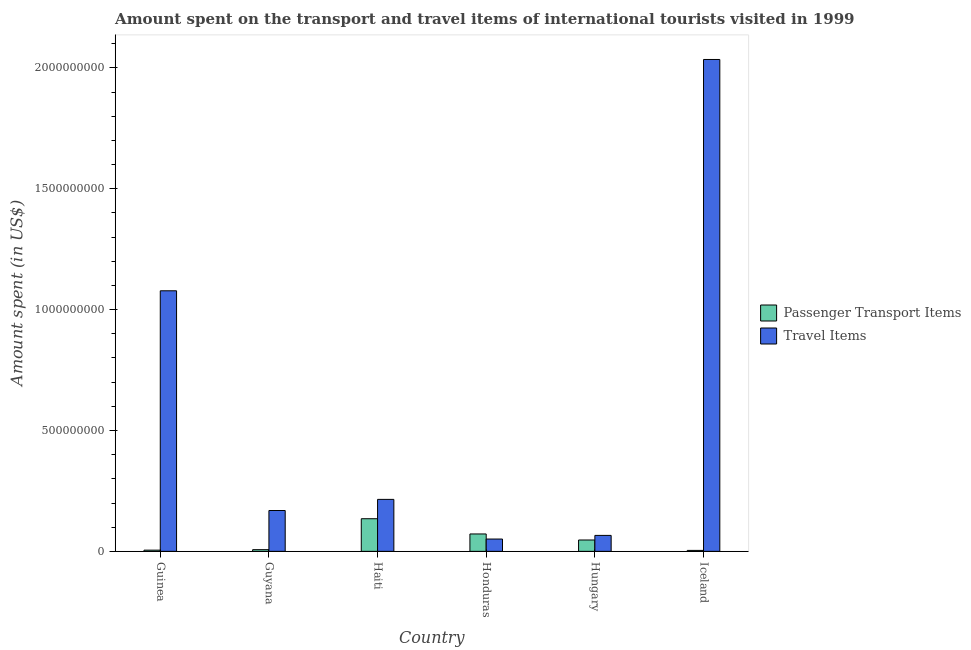How many groups of bars are there?
Keep it short and to the point. 6. Are the number of bars per tick equal to the number of legend labels?
Provide a succinct answer. Yes. Are the number of bars on each tick of the X-axis equal?
Offer a very short reply. Yes. How many bars are there on the 3rd tick from the left?
Make the answer very short. 2. What is the label of the 4th group of bars from the left?
Give a very brief answer. Honduras. In how many cases, is the number of bars for a given country not equal to the number of legend labels?
Provide a short and direct response. 0. What is the amount spent in travel items in Guyana?
Your answer should be very brief. 1.69e+08. Across all countries, what is the maximum amount spent on passenger transport items?
Your answer should be very brief. 1.35e+08. Across all countries, what is the minimum amount spent in travel items?
Your answer should be compact. 5.10e+07. In which country was the amount spent on passenger transport items maximum?
Give a very brief answer. Haiti. In which country was the amount spent in travel items minimum?
Ensure brevity in your answer.  Honduras. What is the total amount spent on passenger transport items in the graph?
Offer a very short reply. 2.70e+08. What is the difference between the amount spent in travel items in Guinea and that in Haiti?
Offer a very short reply. 8.63e+08. What is the difference between the amount spent on passenger transport items in Iceland and the amount spent in travel items in Guinea?
Provide a succinct answer. -1.07e+09. What is the average amount spent in travel items per country?
Ensure brevity in your answer.  6.02e+08. What is the difference between the amount spent in travel items and amount spent on passenger transport items in Honduras?
Make the answer very short. -2.10e+07. What is the ratio of the amount spent on passenger transport items in Haiti to that in Hungary?
Provide a succinct answer. 2.87. Is the amount spent on passenger transport items in Guyana less than that in Honduras?
Your answer should be very brief. Yes. Is the difference between the amount spent on passenger transport items in Hungary and Iceland greater than the difference between the amount spent in travel items in Hungary and Iceland?
Offer a terse response. Yes. What is the difference between the highest and the second highest amount spent in travel items?
Keep it short and to the point. 9.57e+08. What is the difference between the highest and the lowest amount spent on passenger transport items?
Your response must be concise. 1.31e+08. What does the 1st bar from the left in Hungary represents?
Your answer should be compact. Passenger Transport Items. What does the 2nd bar from the right in Guyana represents?
Your response must be concise. Passenger Transport Items. Are all the bars in the graph horizontal?
Provide a short and direct response. No. What is the difference between two consecutive major ticks on the Y-axis?
Provide a succinct answer. 5.00e+08. Are the values on the major ticks of Y-axis written in scientific E-notation?
Offer a terse response. No. Does the graph contain any zero values?
Your response must be concise. No. Where does the legend appear in the graph?
Your response must be concise. Center right. How many legend labels are there?
Your answer should be very brief. 2. How are the legend labels stacked?
Ensure brevity in your answer.  Vertical. What is the title of the graph?
Your answer should be very brief. Amount spent on the transport and travel items of international tourists visited in 1999. Does "Death rate" appear as one of the legend labels in the graph?
Provide a succinct answer. No. What is the label or title of the Y-axis?
Give a very brief answer. Amount spent (in US$). What is the Amount spent (in US$) in Travel Items in Guinea?
Keep it short and to the point. 1.08e+09. What is the Amount spent (in US$) in Passenger Transport Items in Guyana?
Provide a succinct answer. 7.00e+06. What is the Amount spent (in US$) of Travel Items in Guyana?
Provide a succinct answer. 1.69e+08. What is the Amount spent (in US$) of Passenger Transport Items in Haiti?
Provide a succinct answer. 1.35e+08. What is the Amount spent (in US$) of Travel Items in Haiti?
Keep it short and to the point. 2.15e+08. What is the Amount spent (in US$) of Passenger Transport Items in Honduras?
Make the answer very short. 7.20e+07. What is the Amount spent (in US$) of Travel Items in Honduras?
Ensure brevity in your answer.  5.10e+07. What is the Amount spent (in US$) of Passenger Transport Items in Hungary?
Your response must be concise. 4.70e+07. What is the Amount spent (in US$) in Travel Items in Hungary?
Your answer should be compact. 6.60e+07. What is the Amount spent (in US$) of Travel Items in Iceland?
Your answer should be compact. 2.04e+09. Across all countries, what is the maximum Amount spent (in US$) in Passenger Transport Items?
Your response must be concise. 1.35e+08. Across all countries, what is the maximum Amount spent (in US$) in Travel Items?
Your answer should be very brief. 2.04e+09. Across all countries, what is the minimum Amount spent (in US$) of Passenger Transport Items?
Give a very brief answer. 4.00e+06. Across all countries, what is the minimum Amount spent (in US$) in Travel Items?
Provide a succinct answer. 5.10e+07. What is the total Amount spent (in US$) in Passenger Transport Items in the graph?
Your response must be concise. 2.70e+08. What is the total Amount spent (in US$) in Travel Items in the graph?
Keep it short and to the point. 3.61e+09. What is the difference between the Amount spent (in US$) of Passenger Transport Items in Guinea and that in Guyana?
Offer a terse response. -2.00e+06. What is the difference between the Amount spent (in US$) in Travel Items in Guinea and that in Guyana?
Your answer should be compact. 9.09e+08. What is the difference between the Amount spent (in US$) in Passenger Transport Items in Guinea and that in Haiti?
Offer a terse response. -1.30e+08. What is the difference between the Amount spent (in US$) of Travel Items in Guinea and that in Haiti?
Your response must be concise. 8.63e+08. What is the difference between the Amount spent (in US$) in Passenger Transport Items in Guinea and that in Honduras?
Your answer should be very brief. -6.70e+07. What is the difference between the Amount spent (in US$) of Travel Items in Guinea and that in Honduras?
Your answer should be compact. 1.03e+09. What is the difference between the Amount spent (in US$) of Passenger Transport Items in Guinea and that in Hungary?
Offer a terse response. -4.20e+07. What is the difference between the Amount spent (in US$) of Travel Items in Guinea and that in Hungary?
Your answer should be compact. 1.01e+09. What is the difference between the Amount spent (in US$) in Passenger Transport Items in Guinea and that in Iceland?
Your answer should be compact. 1.00e+06. What is the difference between the Amount spent (in US$) of Travel Items in Guinea and that in Iceland?
Offer a terse response. -9.57e+08. What is the difference between the Amount spent (in US$) of Passenger Transport Items in Guyana and that in Haiti?
Offer a terse response. -1.28e+08. What is the difference between the Amount spent (in US$) of Travel Items in Guyana and that in Haiti?
Your response must be concise. -4.60e+07. What is the difference between the Amount spent (in US$) of Passenger Transport Items in Guyana and that in Honduras?
Provide a short and direct response. -6.50e+07. What is the difference between the Amount spent (in US$) of Travel Items in Guyana and that in Honduras?
Provide a succinct answer. 1.18e+08. What is the difference between the Amount spent (in US$) in Passenger Transport Items in Guyana and that in Hungary?
Ensure brevity in your answer.  -4.00e+07. What is the difference between the Amount spent (in US$) of Travel Items in Guyana and that in Hungary?
Offer a very short reply. 1.03e+08. What is the difference between the Amount spent (in US$) in Travel Items in Guyana and that in Iceland?
Make the answer very short. -1.87e+09. What is the difference between the Amount spent (in US$) of Passenger Transport Items in Haiti and that in Honduras?
Ensure brevity in your answer.  6.30e+07. What is the difference between the Amount spent (in US$) of Travel Items in Haiti and that in Honduras?
Ensure brevity in your answer.  1.64e+08. What is the difference between the Amount spent (in US$) in Passenger Transport Items in Haiti and that in Hungary?
Provide a succinct answer. 8.80e+07. What is the difference between the Amount spent (in US$) in Travel Items in Haiti and that in Hungary?
Offer a terse response. 1.49e+08. What is the difference between the Amount spent (in US$) in Passenger Transport Items in Haiti and that in Iceland?
Offer a very short reply. 1.31e+08. What is the difference between the Amount spent (in US$) of Travel Items in Haiti and that in Iceland?
Your answer should be very brief. -1.82e+09. What is the difference between the Amount spent (in US$) of Passenger Transport Items in Honduras and that in Hungary?
Provide a succinct answer. 2.50e+07. What is the difference between the Amount spent (in US$) in Travel Items in Honduras and that in Hungary?
Provide a short and direct response. -1.50e+07. What is the difference between the Amount spent (in US$) of Passenger Transport Items in Honduras and that in Iceland?
Keep it short and to the point. 6.80e+07. What is the difference between the Amount spent (in US$) of Travel Items in Honduras and that in Iceland?
Offer a very short reply. -1.98e+09. What is the difference between the Amount spent (in US$) in Passenger Transport Items in Hungary and that in Iceland?
Give a very brief answer. 4.30e+07. What is the difference between the Amount spent (in US$) in Travel Items in Hungary and that in Iceland?
Keep it short and to the point. -1.97e+09. What is the difference between the Amount spent (in US$) of Passenger Transport Items in Guinea and the Amount spent (in US$) of Travel Items in Guyana?
Keep it short and to the point. -1.64e+08. What is the difference between the Amount spent (in US$) in Passenger Transport Items in Guinea and the Amount spent (in US$) in Travel Items in Haiti?
Offer a very short reply. -2.10e+08. What is the difference between the Amount spent (in US$) in Passenger Transport Items in Guinea and the Amount spent (in US$) in Travel Items in Honduras?
Your response must be concise. -4.60e+07. What is the difference between the Amount spent (in US$) of Passenger Transport Items in Guinea and the Amount spent (in US$) of Travel Items in Hungary?
Make the answer very short. -6.10e+07. What is the difference between the Amount spent (in US$) in Passenger Transport Items in Guinea and the Amount spent (in US$) in Travel Items in Iceland?
Keep it short and to the point. -2.03e+09. What is the difference between the Amount spent (in US$) of Passenger Transport Items in Guyana and the Amount spent (in US$) of Travel Items in Haiti?
Ensure brevity in your answer.  -2.08e+08. What is the difference between the Amount spent (in US$) in Passenger Transport Items in Guyana and the Amount spent (in US$) in Travel Items in Honduras?
Provide a succinct answer. -4.40e+07. What is the difference between the Amount spent (in US$) in Passenger Transport Items in Guyana and the Amount spent (in US$) in Travel Items in Hungary?
Give a very brief answer. -5.90e+07. What is the difference between the Amount spent (in US$) of Passenger Transport Items in Guyana and the Amount spent (in US$) of Travel Items in Iceland?
Provide a short and direct response. -2.03e+09. What is the difference between the Amount spent (in US$) of Passenger Transport Items in Haiti and the Amount spent (in US$) of Travel Items in Honduras?
Your response must be concise. 8.40e+07. What is the difference between the Amount spent (in US$) in Passenger Transport Items in Haiti and the Amount spent (in US$) in Travel Items in Hungary?
Your answer should be compact. 6.90e+07. What is the difference between the Amount spent (in US$) of Passenger Transport Items in Haiti and the Amount spent (in US$) of Travel Items in Iceland?
Provide a short and direct response. -1.90e+09. What is the difference between the Amount spent (in US$) of Passenger Transport Items in Honduras and the Amount spent (in US$) of Travel Items in Hungary?
Offer a terse response. 6.00e+06. What is the difference between the Amount spent (in US$) in Passenger Transport Items in Honduras and the Amount spent (in US$) in Travel Items in Iceland?
Offer a very short reply. -1.96e+09. What is the difference between the Amount spent (in US$) of Passenger Transport Items in Hungary and the Amount spent (in US$) of Travel Items in Iceland?
Provide a succinct answer. -1.99e+09. What is the average Amount spent (in US$) in Passenger Transport Items per country?
Provide a succinct answer. 4.50e+07. What is the average Amount spent (in US$) of Travel Items per country?
Offer a very short reply. 6.02e+08. What is the difference between the Amount spent (in US$) in Passenger Transport Items and Amount spent (in US$) in Travel Items in Guinea?
Your response must be concise. -1.07e+09. What is the difference between the Amount spent (in US$) of Passenger Transport Items and Amount spent (in US$) of Travel Items in Guyana?
Provide a succinct answer. -1.62e+08. What is the difference between the Amount spent (in US$) in Passenger Transport Items and Amount spent (in US$) in Travel Items in Haiti?
Your response must be concise. -8.00e+07. What is the difference between the Amount spent (in US$) in Passenger Transport Items and Amount spent (in US$) in Travel Items in Honduras?
Give a very brief answer. 2.10e+07. What is the difference between the Amount spent (in US$) in Passenger Transport Items and Amount spent (in US$) in Travel Items in Hungary?
Give a very brief answer. -1.90e+07. What is the difference between the Amount spent (in US$) in Passenger Transport Items and Amount spent (in US$) in Travel Items in Iceland?
Your response must be concise. -2.03e+09. What is the ratio of the Amount spent (in US$) of Travel Items in Guinea to that in Guyana?
Your answer should be compact. 6.38. What is the ratio of the Amount spent (in US$) in Passenger Transport Items in Guinea to that in Haiti?
Offer a very short reply. 0.04. What is the ratio of the Amount spent (in US$) of Travel Items in Guinea to that in Haiti?
Your answer should be compact. 5.01. What is the ratio of the Amount spent (in US$) of Passenger Transport Items in Guinea to that in Honduras?
Give a very brief answer. 0.07. What is the ratio of the Amount spent (in US$) of Travel Items in Guinea to that in Honduras?
Your answer should be compact. 21.14. What is the ratio of the Amount spent (in US$) in Passenger Transport Items in Guinea to that in Hungary?
Ensure brevity in your answer.  0.11. What is the ratio of the Amount spent (in US$) in Travel Items in Guinea to that in Hungary?
Your answer should be very brief. 16.33. What is the ratio of the Amount spent (in US$) of Passenger Transport Items in Guinea to that in Iceland?
Your answer should be very brief. 1.25. What is the ratio of the Amount spent (in US$) in Travel Items in Guinea to that in Iceland?
Provide a short and direct response. 0.53. What is the ratio of the Amount spent (in US$) of Passenger Transport Items in Guyana to that in Haiti?
Offer a very short reply. 0.05. What is the ratio of the Amount spent (in US$) in Travel Items in Guyana to that in Haiti?
Give a very brief answer. 0.79. What is the ratio of the Amount spent (in US$) of Passenger Transport Items in Guyana to that in Honduras?
Give a very brief answer. 0.1. What is the ratio of the Amount spent (in US$) of Travel Items in Guyana to that in Honduras?
Provide a succinct answer. 3.31. What is the ratio of the Amount spent (in US$) in Passenger Transport Items in Guyana to that in Hungary?
Keep it short and to the point. 0.15. What is the ratio of the Amount spent (in US$) in Travel Items in Guyana to that in Hungary?
Your answer should be compact. 2.56. What is the ratio of the Amount spent (in US$) of Passenger Transport Items in Guyana to that in Iceland?
Provide a short and direct response. 1.75. What is the ratio of the Amount spent (in US$) of Travel Items in Guyana to that in Iceland?
Give a very brief answer. 0.08. What is the ratio of the Amount spent (in US$) of Passenger Transport Items in Haiti to that in Honduras?
Your response must be concise. 1.88. What is the ratio of the Amount spent (in US$) in Travel Items in Haiti to that in Honduras?
Make the answer very short. 4.22. What is the ratio of the Amount spent (in US$) of Passenger Transport Items in Haiti to that in Hungary?
Ensure brevity in your answer.  2.87. What is the ratio of the Amount spent (in US$) of Travel Items in Haiti to that in Hungary?
Provide a short and direct response. 3.26. What is the ratio of the Amount spent (in US$) of Passenger Transport Items in Haiti to that in Iceland?
Your answer should be very brief. 33.75. What is the ratio of the Amount spent (in US$) of Travel Items in Haiti to that in Iceland?
Keep it short and to the point. 0.11. What is the ratio of the Amount spent (in US$) in Passenger Transport Items in Honduras to that in Hungary?
Your response must be concise. 1.53. What is the ratio of the Amount spent (in US$) in Travel Items in Honduras to that in Hungary?
Give a very brief answer. 0.77. What is the ratio of the Amount spent (in US$) in Travel Items in Honduras to that in Iceland?
Your answer should be very brief. 0.03. What is the ratio of the Amount spent (in US$) in Passenger Transport Items in Hungary to that in Iceland?
Provide a succinct answer. 11.75. What is the ratio of the Amount spent (in US$) of Travel Items in Hungary to that in Iceland?
Offer a terse response. 0.03. What is the difference between the highest and the second highest Amount spent (in US$) in Passenger Transport Items?
Make the answer very short. 6.30e+07. What is the difference between the highest and the second highest Amount spent (in US$) in Travel Items?
Offer a very short reply. 9.57e+08. What is the difference between the highest and the lowest Amount spent (in US$) in Passenger Transport Items?
Offer a very short reply. 1.31e+08. What is the difference between the highest and the lowest Amount spent (in US$) of Travel Items?
Provide a short and direct response. 1.98e+09. 